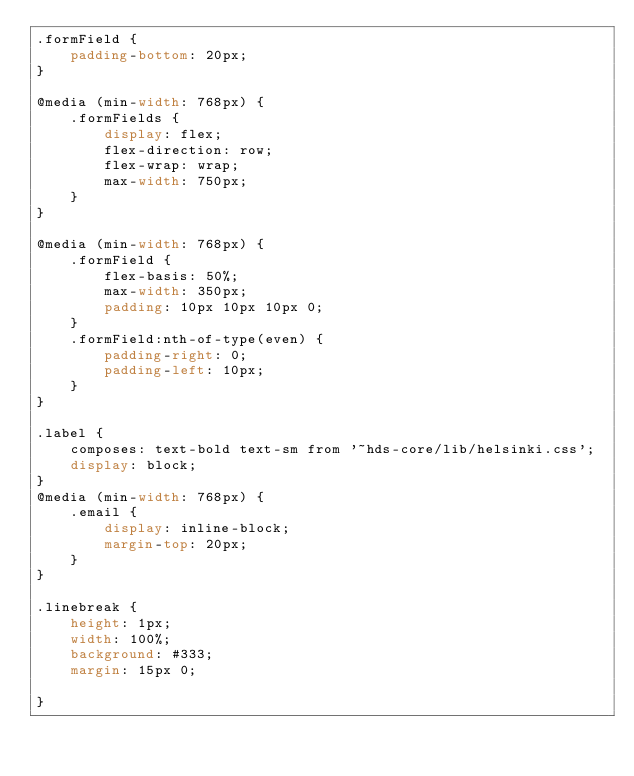Convert code to text. <code><loc_0><loc_0><loc_500><loc_500><_CSS_>.formField {
    padding-bottom: 20px;
}

@media (min-width: 768px) {
    .formFields {
        display: flex;
        flex-direction: row;
        flex-wrap: wrap;
        max-width: 750px;
    }
}

@media (min-width: 768px) {
    .formField {
        flex-basis: 50%;
        max-width: 350px;
        padding: 10px 10px 10px 0;
    }
    .formField:nth-of-type(even) {
        padding-right: 0;
        padding-left: 10px;
    }
}

.label {
    composes: text-bold text-sm from '~hds-core/lib/helsinki.css';
    display: block;
}
@media (min-width: 768px) {
    .email {
        display: inline-block;
        margin-top: 20px;
    }
}

.linebreak {
    height: 1px;
    width: 100%;
    background: #333;
    margin: 15px 0;

}

</code> 